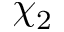<formula> <loc_0><loc_0><loc_500><loc_500>\chi _ { 2 }</formula> 